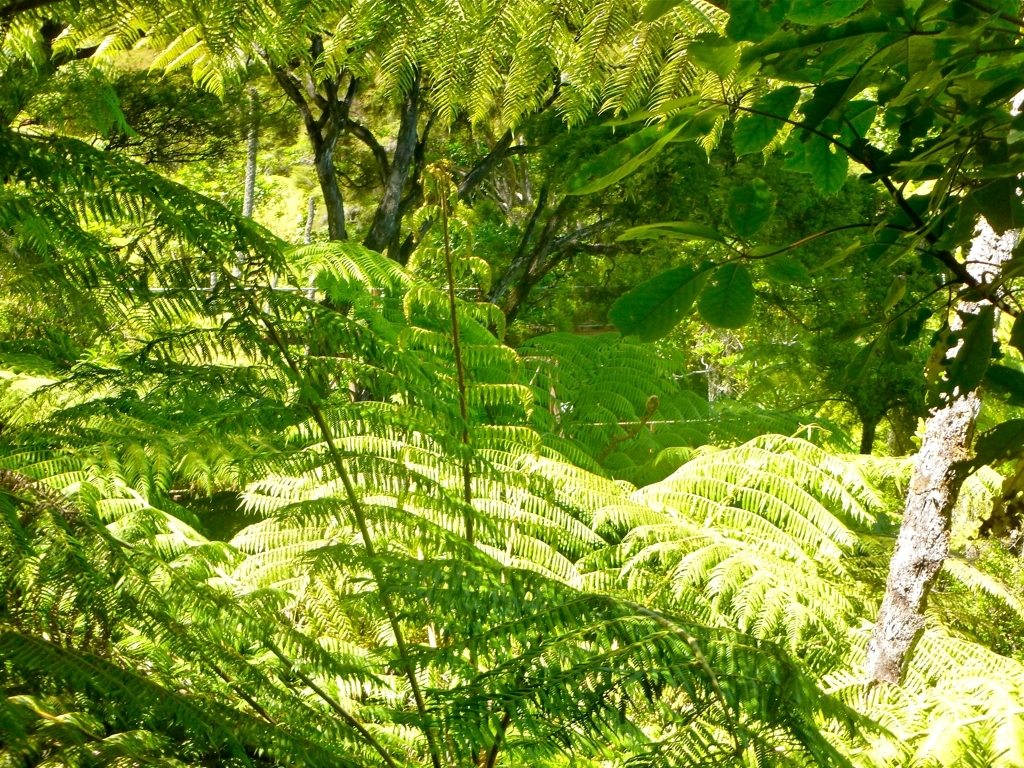What time of day does this photo appear to have been taken? The photo seems to have been taken in the late morning or midday, judging by the bright and well-distributed sunlight filtering through the leaves, casting a mix of light and shadows on the foliage. 